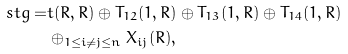Convert formula to latex. <formula><loc_0><loc_0><loc_500><loc_500>\ s t g = & t ( R , R ) \oplus T _ { 1 2 } ( 1 , R ) \oplus T _ { 1 3 } ( 1 , R ) \oplus T _ { 1 4 } ( 1 , R ) \\ & \oplus _ { 1 \leq i \neq j \leq n } X _ { i j } ( R ) ,</formula> 